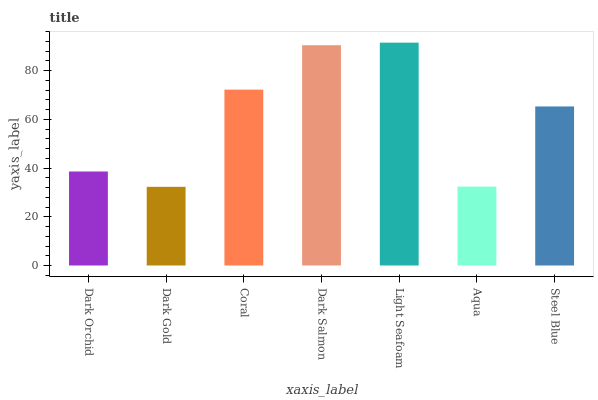Is Dark Gold the minimum?
Answer yes or no. Yes. Is Light Seafoam the maximum?
Answer yes or no. Yes. Is Coral the minimum?
Answer yes or no. No. Is Coral the maximum?
Answer yes or no. No. Is Coral greater than Dark Gold?
Answer yes or no. Yes. Is Dark Gold less than Coral?
Answer yes or no. Yes. Is Dark Gold greater than Coral?
Answer yes or no. No. Is Coral less than Dark Gold?
Answer yes or no. No. Is Steel Blue the high median?
Answer yes or no. Yes. Is Steel Blue the low median?
Answer yes or no. Yes. Is Dark Salmon the high median?
Answer yes or no. No. Is Dark Gold the low median?
Answer yes or no. No. 